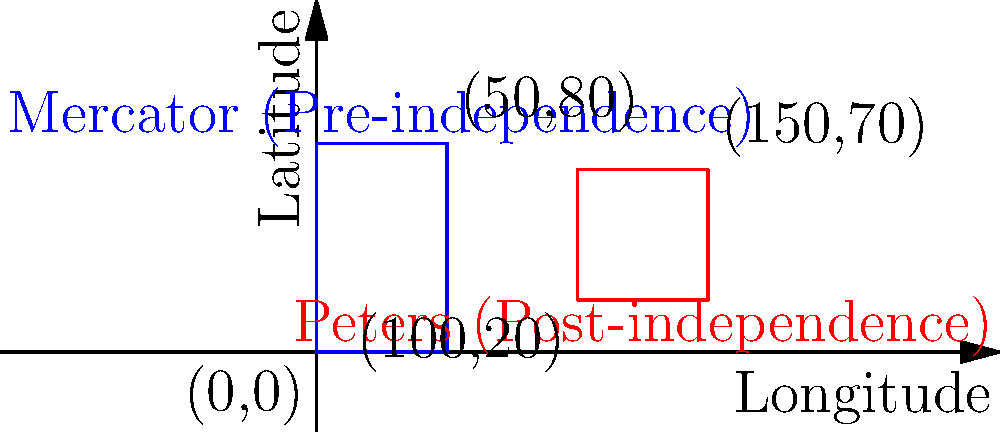Compare the representations of Mozambique using the Mercator projection (pre-independence) and the Peters projection (post-independence) in the coordinate system. What is the primary difference in the depiction of Mozambique's shape and size between these two projections, and how might this relate to the country's struggle for independence? To answer this question, let's analyze the two projections step-by-step:

1. Mercator projection (pre-independence):
   - Represented by the blue rectangle from (0,0) to (50,80)
   - Taller and narrower shape
   - Covers a larger vertical range (0 to 80 on the y-axis)

2. Peters projection (post-independence):
   - Represented by the red rectangle from (100,20) to (150,70)
   - Wider and shorter shape
   - Covers a smaller vertical range (20 to 70 on the y-axis)

3. Key differences:
   - The Peters projection shows Mozambique as wider and less elongated compared to the Mercator projection.
   - The Peters projection represents the country's area more accurately, while the Mercator projection exaggerates the size of areas farther from the equator.

4. Relation to independence struggle:
   - The Mercator projection, developed during the colonial era, tends to exaggerate the size of European countries and minimize the size of African countries like Mozambique.
   - The Peters projection, developed in the 1970s, aimed to represent land masses more accurately in terms of relative size, particularly benefiting countries in the Global South.
   - The shift from Mercator to Peters projection symbolizes a move away from Eurocentric cartography, aligning with Mozambique's struggle for independence and self-representation.

5. Significance:
   - The change in projection reflects a broader decolonization process, not just politically but also in terms of how African countries are represented and perceived globally.
   - The more accurate representation in the Peters projection can be seen as a form of cartographic justice, giving Mozambique a more proportionate visual presence on world maps.
Answer: The Peters projection shows Mozambique as wider and less vertically stretched, representing its area more accurately and symbolizing a shift from Eurocentric cartography to support decolonization and self-representation. 